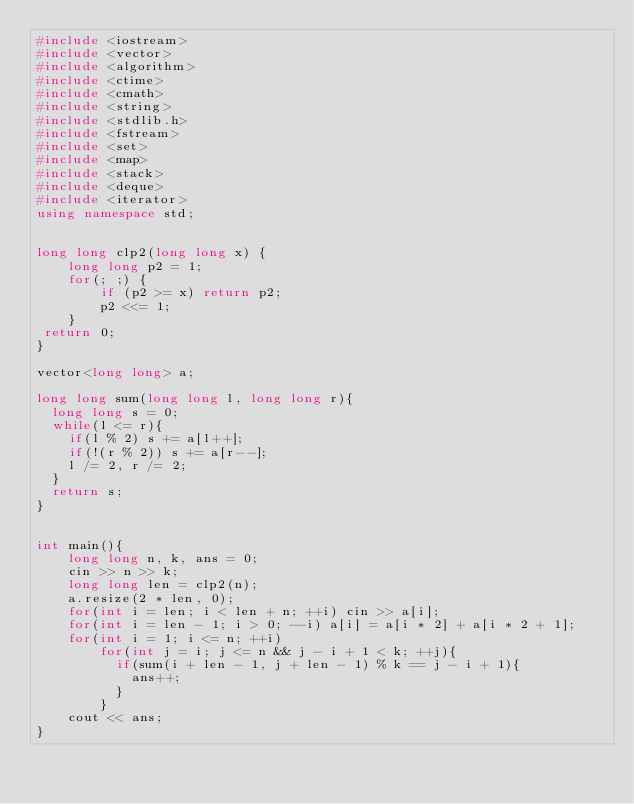Convert code to text. <code><loc_0><loc_0><loc_500><loc_500><_C++_>#include <iostream>
#include <vector>
#include <algorithm>
#include <ctime>
#include <cmath>
#include <string>
#include <stdlib.h>
#include <fstream>
#include <set>
#include <map>
#include <stack>
#include <deque>
#include <iterator>
using namespace std;


long long clp2(long long x) {
    long long p2 = 1;
    for(; ;) {
        if (p2 >= x) return p2;
        p2 <<= 1;
    }
 return 0;
}

vector<long long> a;

long long sum(long long l, long long r){
  long long s = 0;
  while(l <= r){
    if(l % 2) s += a[l++];
    if(!(r % 2)) s += a[r--];
    l /= 2, r /= 2;
  }
  return s;
}


int main(){
    long long n, k, ans = 0;
    cin >> n >> k;
    long long len = clp2(n);
    a.resize(2 * len, 0);
    for(int i = len; i < len + n; ++i) cin >> a[i];
    for(int i = len - 1; i > 0; --i) a[i] = a[i * 2] + a[i * 2 + 1];
    for(int i = 1; i <= n; ++i)
        for(int j = i; j <= n && j - i + 1 < k; ++j){
          if(sum(i + len - 1, j + len - 1) % k == j - i + 1){
            ans++;
          }
        }
    cout << ans;
}
</code> 